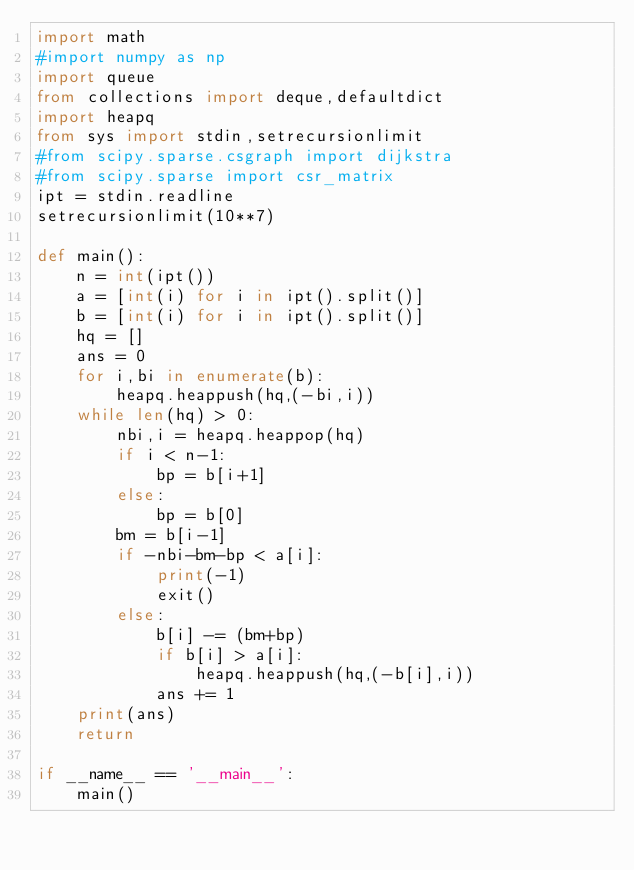Convert code to text. <code><loc_0><loc_0><loc_500><loc_500><_Python_>import math
#import numpy as np
import queue
from collections import deque,defaultdict
import heapq
from sys import stdin,setrecursionlimit
#from scipy.sparse.csgraph import dijkstra
#from scipy.sparse import csr_matrix
ipt = stdin.readline
setrecursionlimit(10**7)

def main():
    n = int(ipt())
    a = [int(i) for i in ipt().split()]
    b = [int(i) for i in ipt().split()]
    hq = []
    ans = 0
    for i,bi in enumerate(b):
        heapq.heappush(hq,(-bi,i))
    while len(hq) > 0:
        nbi,i = heapq.heappop(hq)
        if i < n-1:
            bp = b[i+1]
        else:
            bp = b[0]
        bm = b[i-1]
        if -nbi-bm-bp < a[i]:
            print(-1)
            exit()
        else:
            b[i] -= (bm+bp)
            if b[i] > a[i]:
                heapq.heappush(hq,(-b[i],i))
            ans += 1
    print(ans)
    return

if __name__ == '__main__':
    main()
</code> 